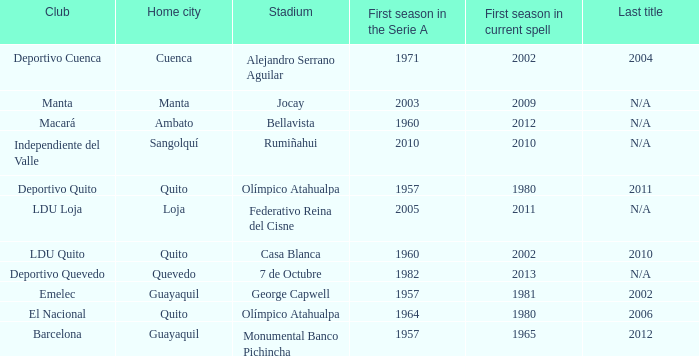Name the last title for 2012 N/A. 